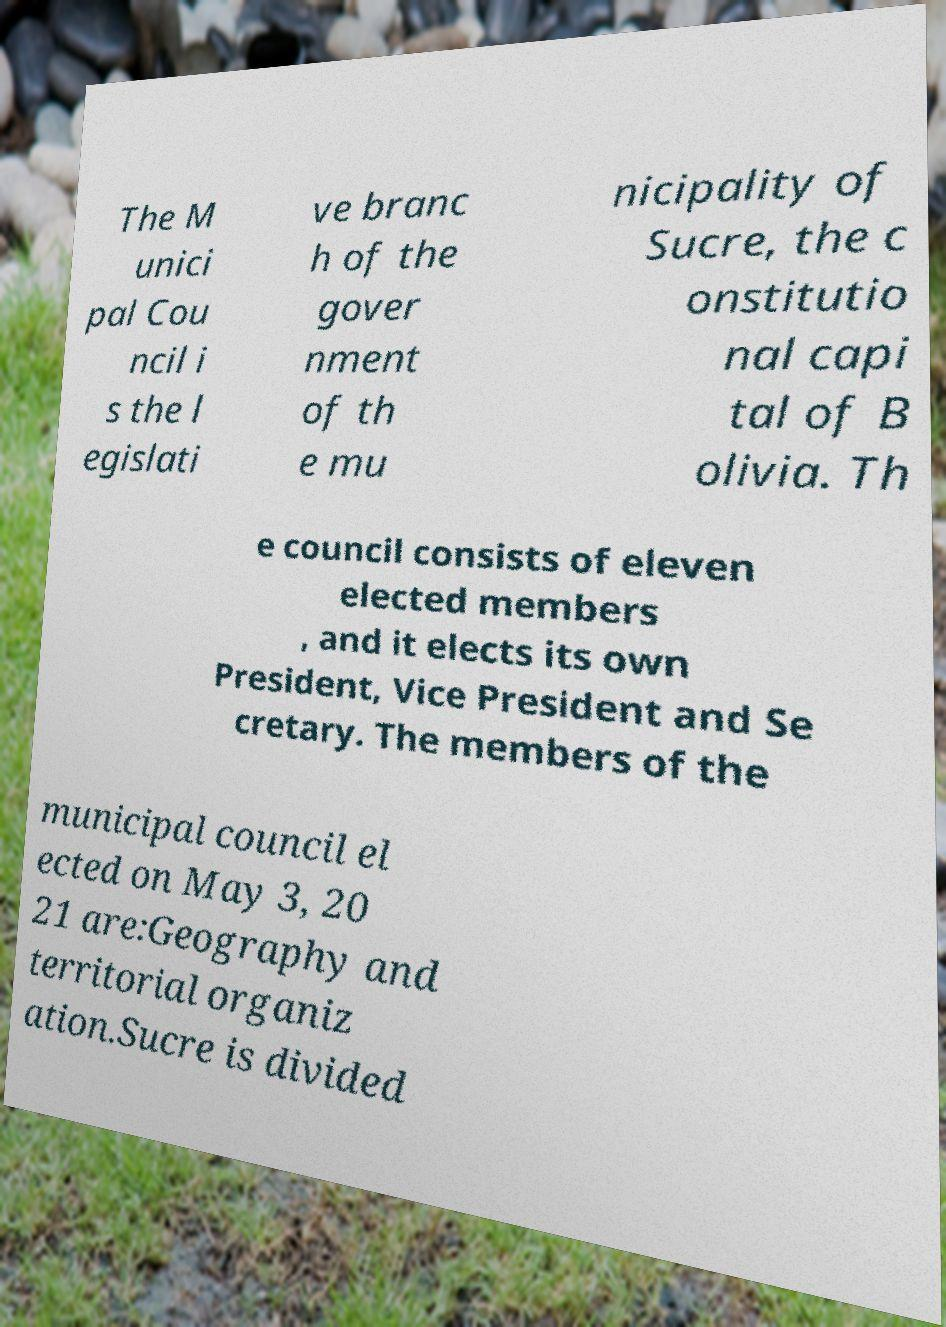For documentation purposes, I need the text within this image transcribed. Could you provide that? The M unici pal Cou ncil i s the l egislati ve branc h of the gover nment of th e mu nicipality of Sucre, the c onstitutio nal capi tal of B olivia. Th e council consists of eleven elected members , and it elects its own President, Vice President and Se cretary. The members of the municipal council el ected on May 3, 20 21 are:Geography and territorial organiz ation.Sucre is divided 